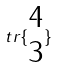<formula> <loc_0><loc_0><loc_500><loc_500>t r \{ \begin{matrix} 4 \\ 3 \end{matrix} \}</formula> 